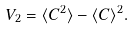<formula> <loc_0><loc_0><loc_500><loc_500>V _ { 2 } = \langle C ^ { 2 } \rangle - \langle C \rangle ^ { 2 } .</formula> 